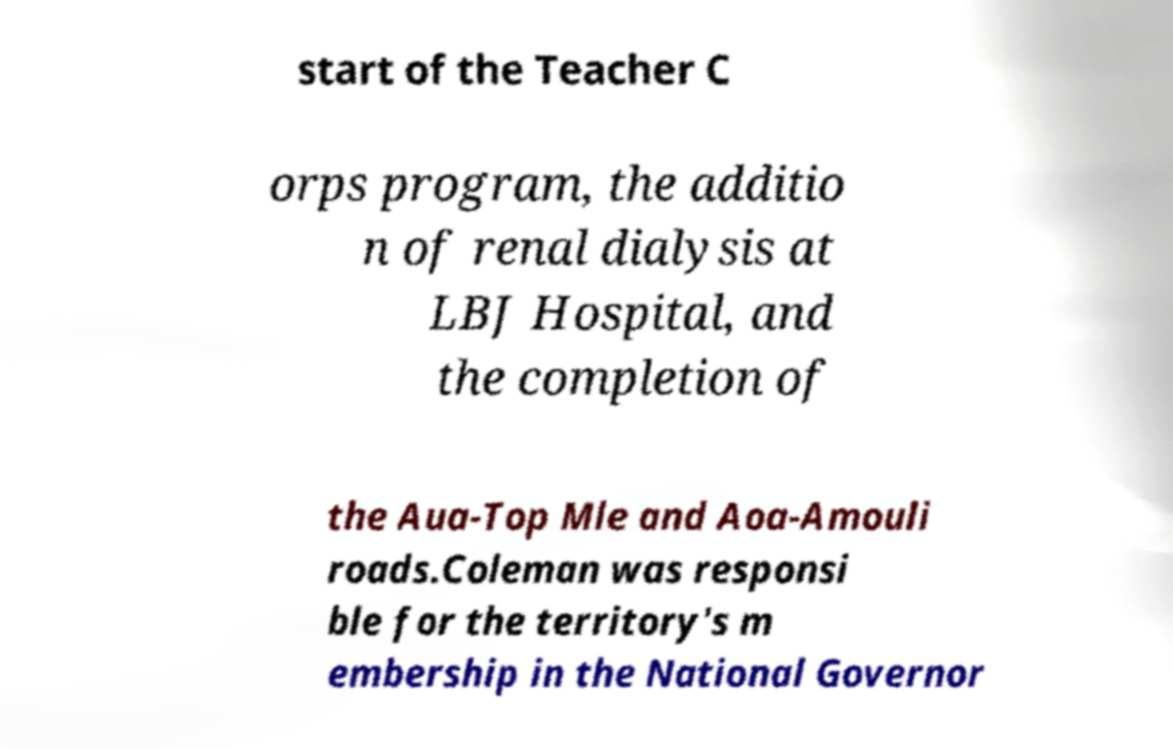Can you read and provide the text displayed in the image?This photo seems to have some interesting text. Can you extract and type it out for me? start of the Teacher C orps program, the additio n of renal dialysis at LBJ Hospital, and the completion of the Aua-Top Mle and Aoa-Amouli roads.Coleman was responsi ble for the territory's m embership in the National Governor 